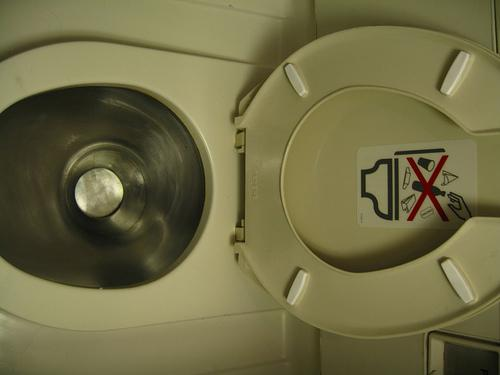Question: what plumbing fixture is pictured?
Choices:
A. Sink.
B. Shower.
C. Toilet.
D. Bathtub.
Answer with the letter. Answer: C Question: how many toilet seat support tabs are pictured?
Choices:
A. Six.
B. Two.
C. Four.
D. One.
Answer with the letter. Answer: C Question: where in the picture is the x, directionally?
Choices:
A. Left.
B. North.
C. South.
D. Right.
Answer with the letter. Answer: D Question: what color is the very bottom of the toilet bowl?
Choices:
A. Silver.
B. White.
C. Brown.
D. Beige.
Answer with the letter. Answer: A Question: what color are the toilet seat support pads?
Choices:
A. Beige.
B. Tan.
C. White.
D. Blue.
Answer with the letter. Answer: C Question: what color is the toilet bowl and seat?
Choices:
A. Beige.
B. White.
C. Light blue.
D. Pink.
Answer with the letter. Answer: A Question: how many people are pictured?
Choices:
A. None.
B. Zero.
C. One.
D. Several.
Answer with the letter. Answer: A 